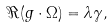<formula> <loc_0><loc_0><loc_500><loc_500>\Re ( g \cdot \Omega ) = \lambda \gamma ,</formula> 